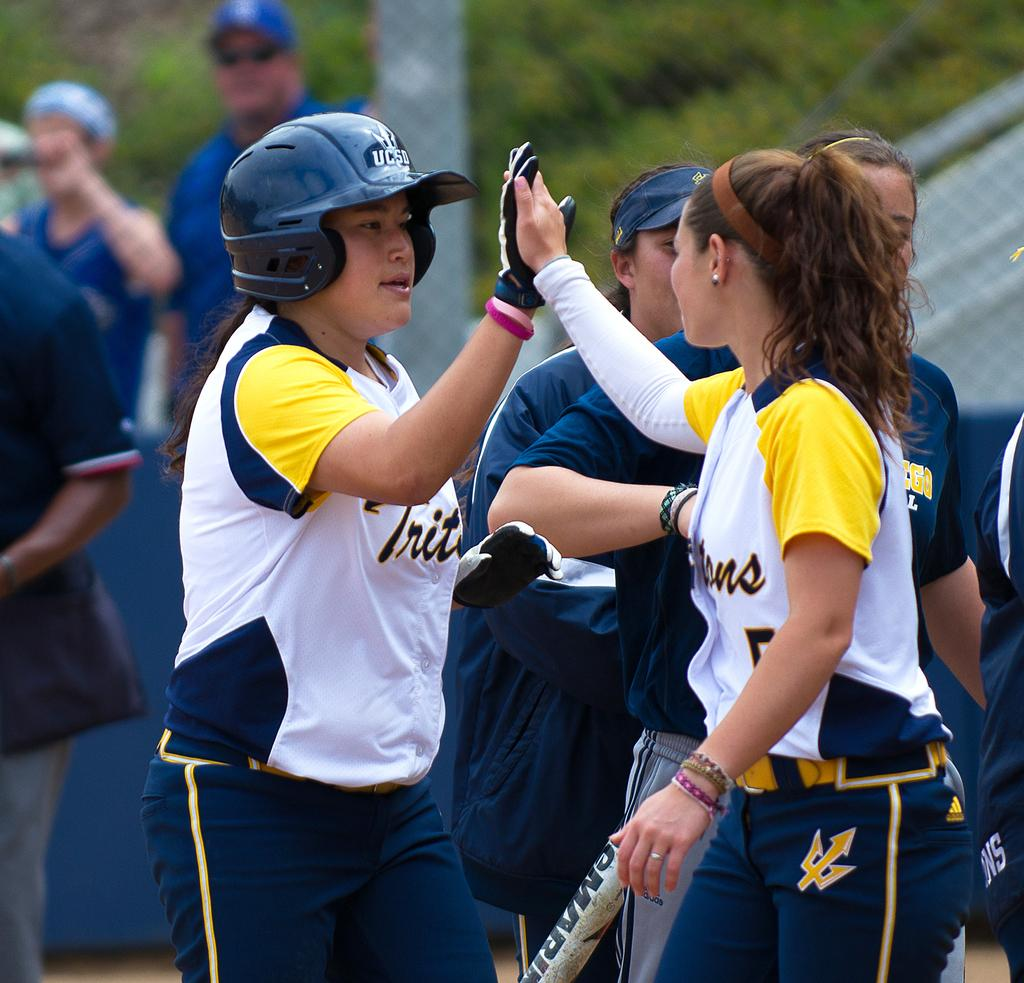How many persons can be seen in the image? There are persons in the image, but the exact number is not specified. What other objects are present in the image besides the persons? There are other objects in the image, but their specific nature is not mentioned. What type of vegetation is visible in the background of the image? There is grass in the background of the image. What else can be seen in the background of the image? There are other objects in the background of the image, but their specific nature is not mentioned. What type of cap is being worn by the person in the image? There is no mention of a cap or any specific clothing item in the image. Is there any snow visible in the image? There is no mention of snow or any weather-related elements in the image. What message of peace is being conveyed in the image? There is no mention of any message or theme related to peace in the image. 